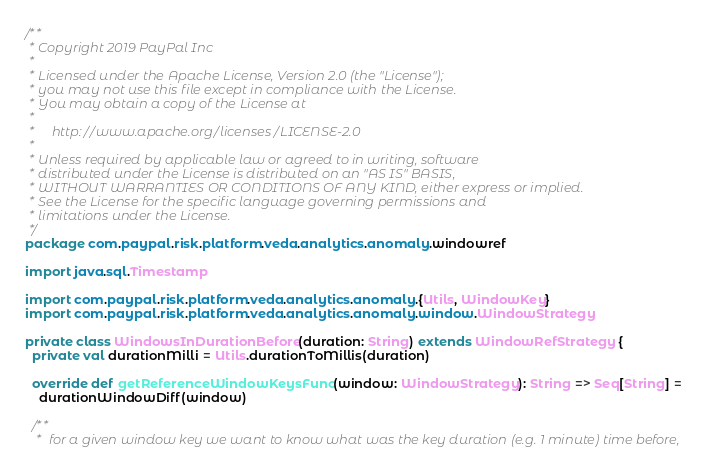Convert code to text. <code><loc_0><loc_0><loc_500><loc_500><_Scala_>/**
 * Copyright 2019 PayPal Inc
 *
 * Licensed under the Apache License, Version 2.0 (the "License");
 * you may not use this file except in compliance with the License.
 * You may obtain a copy of the License at
 *
 *     http://www.apache.org/licenses/LICENSE-2.0
 *
 * Unless required by applicable law or agreed to in writing, software
 * distributed under the License is distributed on an "AS IS" BASIS,
 * WITHOUT WARRANTIES OR CONDITIONS OF ANY KIND, either express or implied.
 * See the License for the specific language governing permissions and
 * limitations under the License.
 */
package com.paypal.risk.platform.veda.analytics.anomaly.windowref

import java.sql.Timestamp

import com.paypal.risk.platform.veda.analytics.anomaly.{Utils, WindowKey}
import com.paypal.risk.platform.veda.analytics.anomaly.window.WindowStrategy

private class WindowsInDurationBefore(duration: String) extends WindowRefStrategy {
  private val durationMilli = Utils.durationToMillis(duration)

  override def getReferenceWindowKeysFunc(window: WindowStrategy): String => Seq[String] =
    durationWindowDiff(window)

  /**
   *  for a given window key we want to know what was the key duration (e.g. 1 minute) time before,</code> 